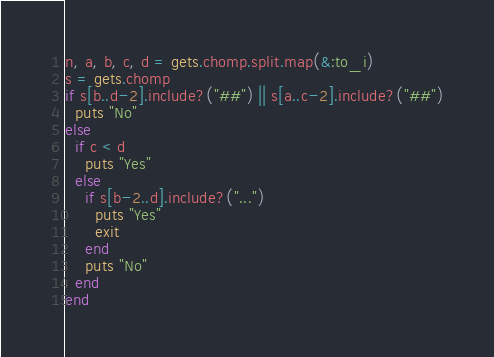Convert code to text. <code><loc_0><loc_0><loc_500><loc_500><_Ruby_>n, a, b, c, d = gets.chomp.split.map(&:to_i)
s = gets.chomp
if s[b..d-2].include?("##") || s[a..c-2].include?("##")
  puts "No"
else
  if c < d
    puts "Yes"
  else
    if s[b-2..d].include?("...")
      puts "Yes"
      exit
  	end
    puts "No"
  end
end</code> 